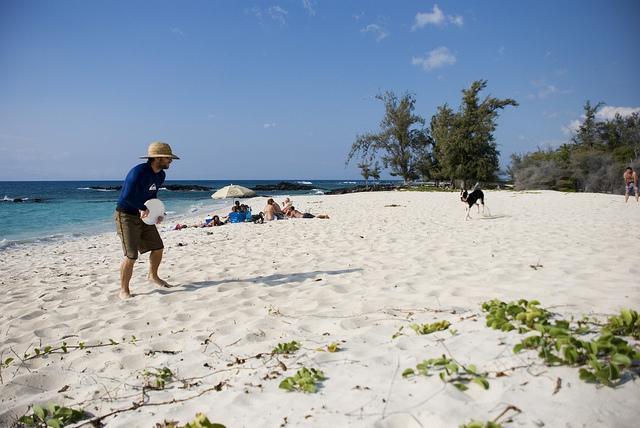How many giraffes are in this picture?
Give a very brief answer. 0. 